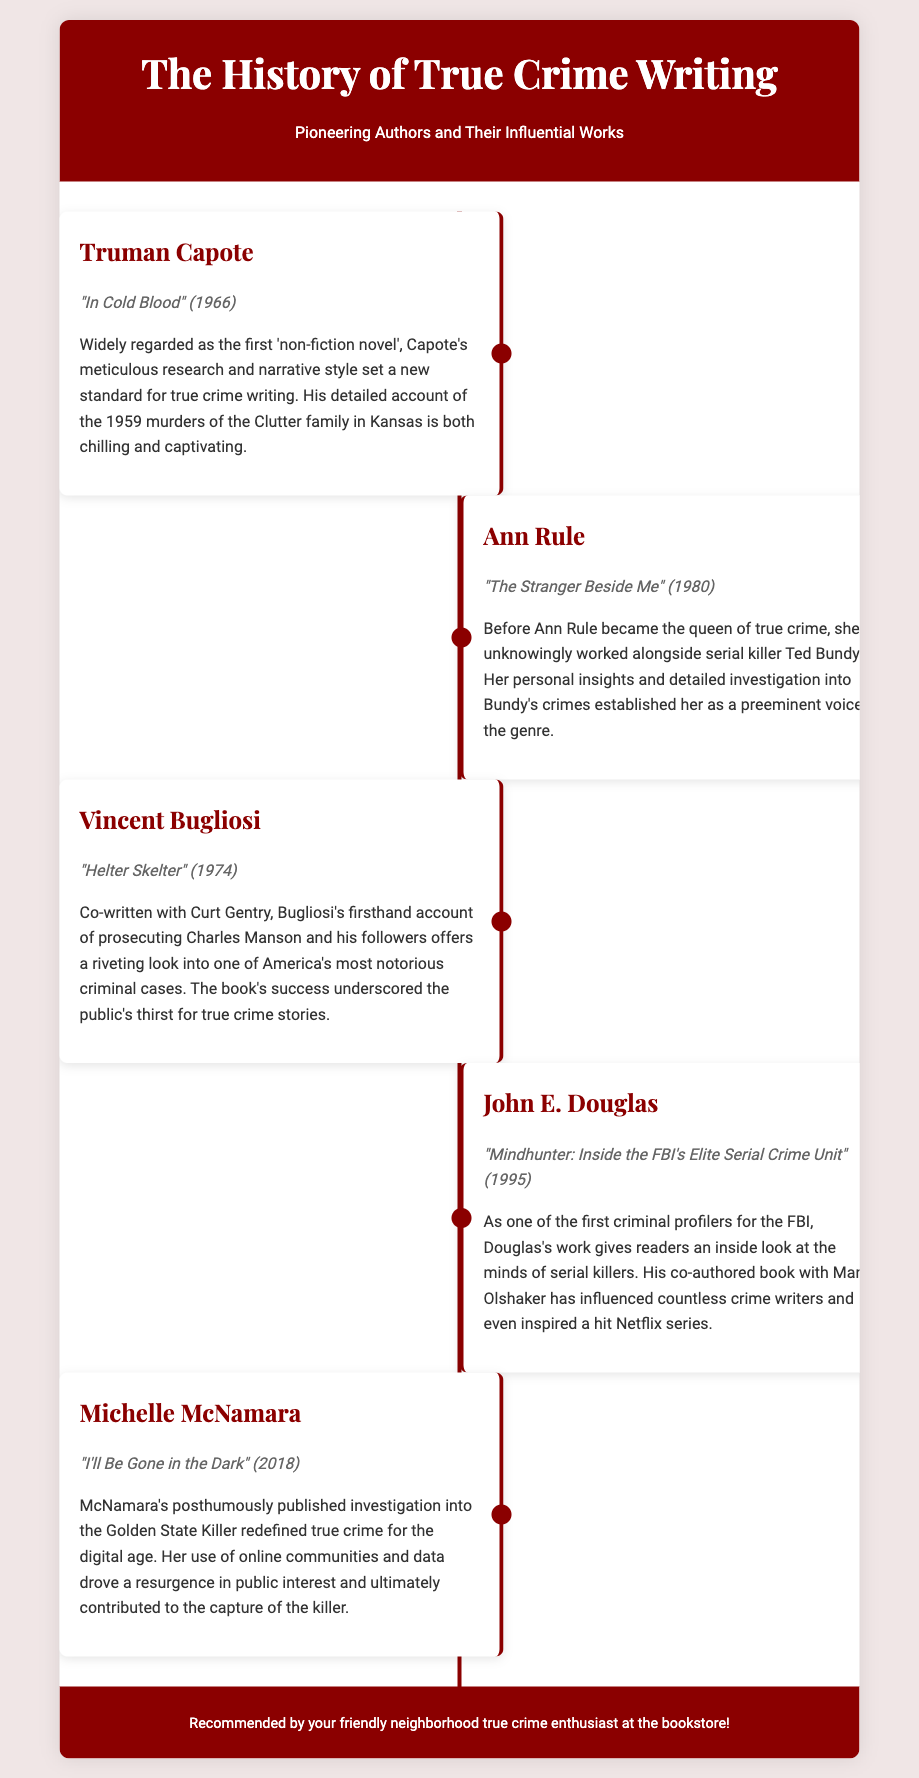What is the title of Truman Capote's famous true crime book? The title of the book is stated as "In Cold Blood" published in 1966.
Answer: "In Cold Blood" Who is the author of "The Stranger Beside Me"? The author of the book is identified as Ann Rule, who published it in 1980.
Answer: Ann Rule What criminal case does Vincent Bugliosi's book revolve around? The book "Helter Skelter" focuses on the prosecution of Charles Manson and his followers.
Answer: Charles Manson In what year was "Mindhunter: Inside the FBI's Elite Serial Crime Unit" published? The publication year of "Mindhunter" is mentioned as 1995.
Answer: 1995 What significant investigation was Michelle McNamara known for? McNamara's investigation centered on the Golden State Killer, as mentioned in her book published in 2018.
Answer: Golden State Killer Which author worked as a criminal profiler for the FBI? John E. Douglas, as noted in the timeline entry, worked as a criminal profiler.
Answer: John E. Douglas How did Michelle McNamara contribute to true crime in the digital age? McNamara's use of online communities and data is highlighted as a key contribution to modern true crime.
Answer: Online communities What was a notable theme in the works of the authors listed? The common theme among the works is their detailed investigations of notorious crimes and criminals.
Answer: Notorious crimes What overarching genre do all these books belong to? The books discussed are all part of the true crime genre, which is explicitly stated.
Answer: True crime 